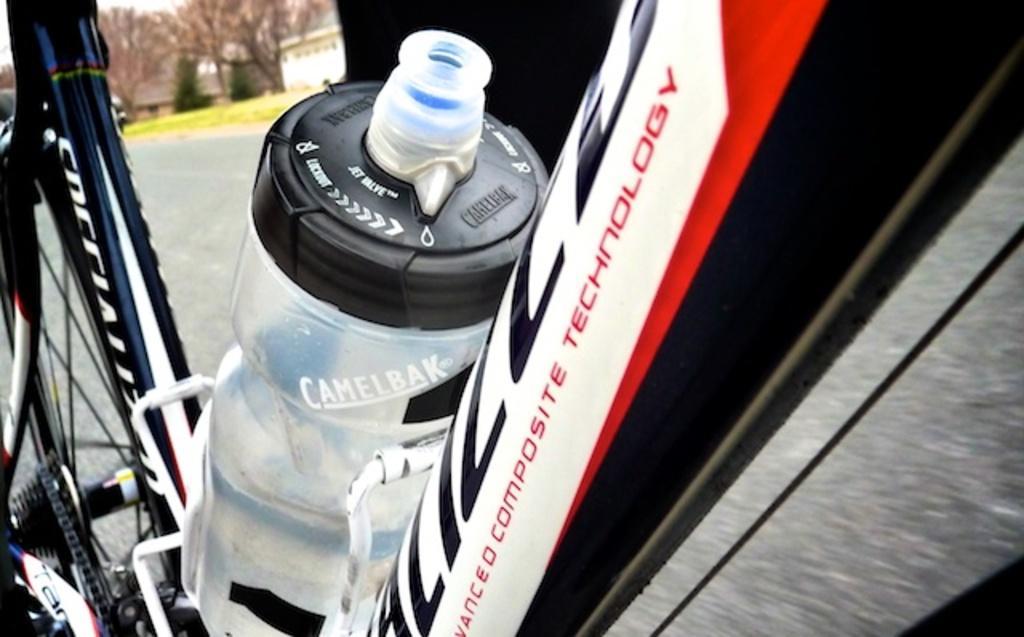In one or two sentences, can you explain what this image depicts? In this image, we can see a bicycle. There is bottle in the middle of the image. 